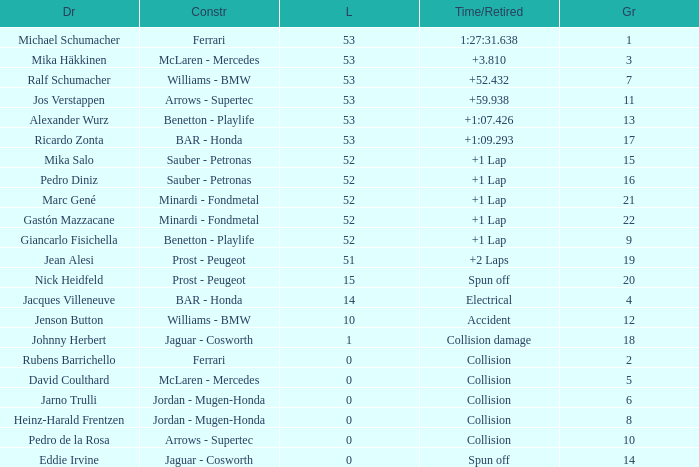What is the grid number with less than 52 laps and a Time/Retired of collision, and a Constructor of arrows - supertec? 1.0. 